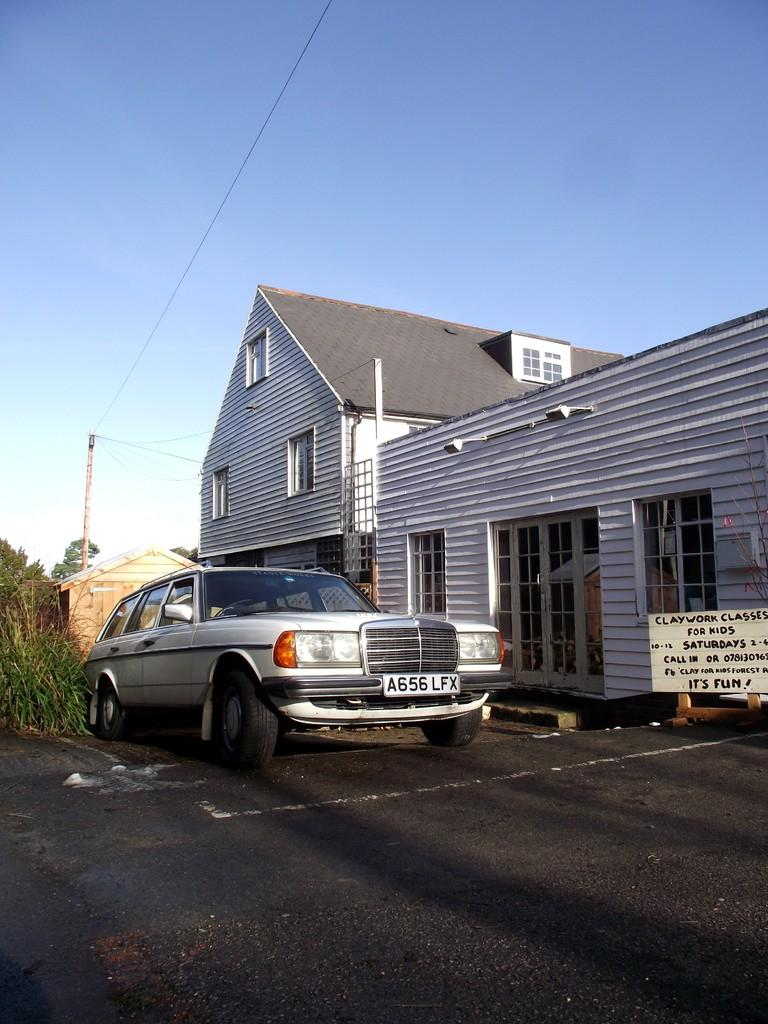What type of structure is in the image? There is a house in the image. What feature of the house is mentioned in the facts? The house has windows. What else can be seen in the image besides the house? There is a car on the road and plants visible in the image. What part of the natural environment is visible in the image? The sky is visible in the image. What word is written on the car in the image? There is no word written on the car in the image. How much force is being applied to the plants in the image? There is no indication of force being applied to the plants in the image. 